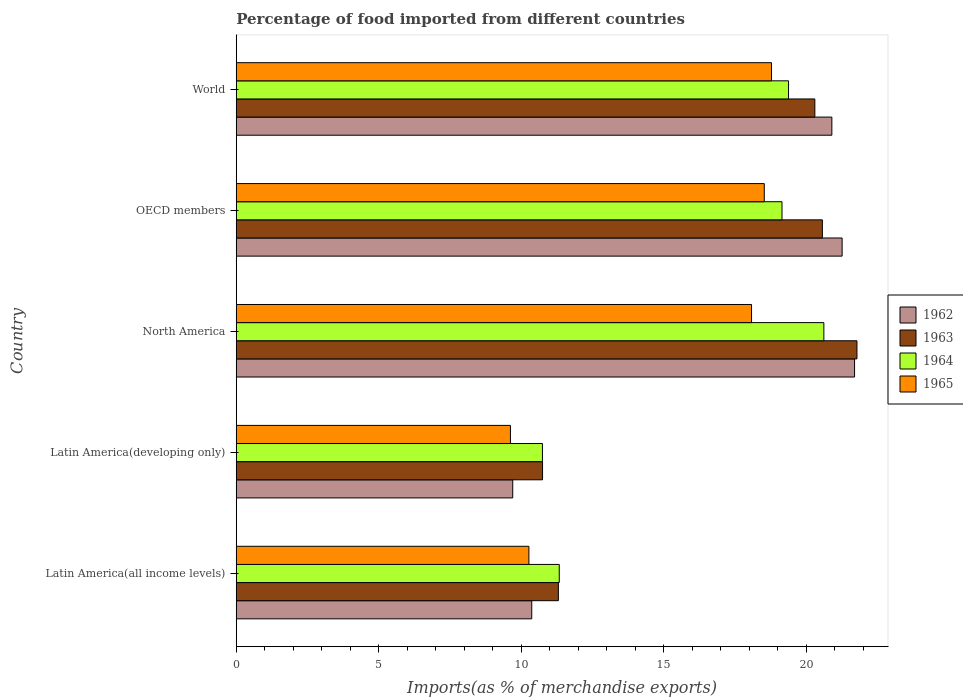How many bars are there on the 3rd tick from the top?
Keep it short and to the point. 4. How many bars are there on the 2nd tick from the bottom?
Make the answer very short. 4. What is the label of the 5th group of bars from the top?
Ensure brevity in your answer.  Latin America(all income levels). What is the percentage of imports to different countries in 1964 in Latin America(developing only)?
Keep it short and to the point. 10.74. Across all countries, what is the maximum percentage of imports to different countries in 1964?
Your answer should be compact. 20.61. Across all countries, what is the minimum percentage of imports to different countries in 1965?
Provide a succinct answer. 9.62. In which country was the percentage of imports to different countries in 1964 maximum?
Offer a terse response. North America. In which country was the percentage of imports to different countries in 1964 minimum?
Make the answer very short. Latin America(developing only). What is the total percentage of imports to different countries in 1964 in the graph?
Offer a very short reply. 81.19. What is the difference between the percentage of imports to different countries in 1962 in Latin America(all income levels) and that in Latin America(developing only)?
Give a very brief answer. 0.67. What is the difference between the percentage of imports to different countries in 1963 in Latin America(all income levels) and the percentage of imports to different countries in 1965 in North America?
Offer a very short reply. -6.78. What is the average percentage of imports to different countries in 1965 per country?
Keep it short and to the point. 15.05. What is the difference between the percentage of imports to different countries in 1964 and percentage of imports to different countries in 1965 in OECD members?
Keep it short and to the point. 0.62. What is the ratio of the percentage of imports to different countries in 1963 in Latin America(developing only) to that in OECD members?
Keep it short and to the point. 0.52. Is the difference between the percentage of imports to different countries in 1964 in North America and World greater than the difference between the percentage of imports to different countries in 1965 in North America and World?
Keep it short and to the point. Yes. What is the difference between the highest and the second highest percentage of imports to different countries in 1965?
Your answer should be compact. 0.25. What is the difference between the highest and the lowest percentage of imports to different countries in 1965?
Provide a succinct answer. 9.16. What does the 2nd bar from the top in Latin America(developing only) represents?
Your answer should be compact. 1964. What does the 1st bar from the bottom in OECD members represents?
Make the answer very short. 1962. Is it the case that in every country, the sum of the percentage of imports to different countries in 1965 and percentage of imports to different countries in 1964 is greater than the percentage of imports to different countries in 1963?
Offer a very short reply. Yes. How many countries are there in the graph?
Ensure brevity in your answer.  5. What is the difference between two consecutive major ticks on the X-axis?
Make the answer very short. 5. Does the graph contain any zero values?
Give a very brief answer. No. Where does the legend appear in the graph?
Ensure brevity in your answer.  Center right. How many legend labels are there?
Your answer should be compact. 4. How are the legend labels stacked?
Your response must be concise. Vertical. What is the title of the graph?
Your response must be concise. Percentage of food imported from different countries. Does "1984" appear as one of the legend labels in the graph?
Provide a short and direct response. No. What is the label or title of the X-axis?
Make the answer very short. Imports(as % of merchandise exports). What is the Imports(as % of merchandise exports) in 1962 in Latin America(all income levels)?
Keep it short and to the point. 10.36. What is the Imports(as % of merchandise exports) in 1963 in Latin America(all income levels)?
Offer a very short reply. 11.3. What is the Imports(as % of merchandise exports) in 1964 in Latin America(all income levels)?
Offer a very short reply. 11.33. What is the Imports(as % of merchandise exports) of 1965 in Latin America(all income levels)?
Your response must be concise. 10.26. What is the Imports(as % of merchandise exports) of 1962 in Latin America(developing only)?
Your response must be concise. 9.7. What is the Imports(as % of merchandise exports) in 1963 in Latin America(developing only)?
Your answer should be very brief. 10.74. What is the Imports(as % of merchandise exports) in 1964 in Latin America(developing only)?
Offer a terse response. 10.74. What is the Imports(as % of merchandise exports) in 1965 in Latin America(developing only)?
Ensure brevity in your answer.  9.62. What is the Imports(as % of merchandise exports) of 1962 in North America?
Your answer should be compact. 21.69. What is the Imports(as % of merchandise exports) of 1963 in North America?
Your answer should be compact. 21.77. What is the Imports(as % of merchandise exports) in 1964 in North America?
Keep it short and to the point. 20.61. What is the Imports(as % of merchandise exports) in 1965 in North America?
Your answer should be very brief. 18.07. What is the Imports(as % of merchandise exports) of 1962 in OECD members?
Offer a terse response. 21.25. What is the Imports(as % of merchandise exports) in 1963 in OECD members?
Your answer should be compact. 20.56. What is the Imports(as % of merchandise exports) of 1964 in OECD members?
Provide a succinct answer. 19.14. What is the Imports(as % of merchandise exports) of 1965 in OECD members?
Your answer should be very brief. 18.52. What is the Imports(as % of merchandise exports) of 1962 in World?
Offer a very short reply. 20.89. What is the Imports(as % of merchandise exports) in 1963 in World?
Your answer should be compact. 20.29. What is the Imports(as % of merchandise exports) of 1964 in World?
Offer a terse response. 19.37. What is the Imports(as % of merchandise exports) in 1965 in World?
Make the answer very short. 18.77. Across all countries, what is the maximum Imports(as % of merchandise exports) of 1962?
Offer a very short reply. 21.69. Across all countries, what is the maximum Imports(as % of merchandise exports) in 1963?
Your answer should be compact. 21.77. Across all countries, what is the maximum Imports(as % of merchandise exports) in 1964?
Give a very brief answer. 20.61. Across all countries, what is the maximum Imports(as % of merchandise exports) in 1965?
Make the answer very short. 18.77. Across all countries, what is the minimum Imports(as % of merchandise exports) in 1962?
Your response must be concise. 9.7. Across all countries, what is the minimum Imports(as % of merchandise exports) of 1963?
Your response must be concise. 10.74. Across all countries, what is the minimum Imports(as % of merchandise exports) in 1964?
Offer a very short reply. 10.74. Across all countries, what is the minimum Imports(as % of merchandise exports) of 1965?
Your answer should be compact. 9.62. What is the total Imports(as % of merchandise exports) in 1962 in the graph?
Provide a succinct answer. 83.89. What is the total Imports(as % of merchandise exports) in 1963 in the graph?
Give a very brief answer. 84.66. What is the total Imports(as % of merchandise exports) in 1964 in the graph?
Offer a very short reply. 81.19. What is the total Imports(as % of merchandise exports) in 1965 in the graph?
Make the answer very short. 75.25. What is the difference between the Imports(as % of merchandise exports) in 1962 in Latin America(all income levels) and that in Latin America(developing only)?
Keep it short and to the point. 0.67. What is the difference between the Imports(as % of merchandise exports) of 1963 in Latin America(all income levels) and that in Latin America(developing only)?
Provide a succinct answer. 0.56. What is the difference between the Imports(as % of merchandise exports) in 1964 in Latin America(all income levels) and that in Latin America(developing only)?
Provide a succinct answer. 0.59. What is the difference between the Imports(as % of merchandise exports) of 1965 in Latin America(all income levels) and that in Latin America(developing only)?
Your response must be concise. 0.65. What is the difference between the Imports(as % of merchandise exports) in 1962 in Latin America(all income levels) and that in North America?
Your response must be concise. -11.32. What is the difference between the Imports(as % of merchandise exports) in 1963 in Latin America(all income levels) and that in North America?
Offer a terse response. -10.47. What is the difference between the Imports(as % of merchandise exports) in 1964 in Latin America(all income levels) and that in North America?
Give a very brief answer. -9.28. What is the difference between the Imports(as % of merchandise exports) of 1965 in Latin America(all income levels) and that in North America?
Your response must be concise. -7.81. What is the difference between the Imports(as % of merchandise exports) in 1962 in Latin America(all income levels) and that in OECD members?
Make the answer very short. -10.89. What is the difference between the Imports(as % of merchandise exports) of 1963 in Latin America(all income levels) and that in OECD members?
Offer a very short reply. -9.26. What is the difference between the Imports(as % of merchandise exports) in 1964 in Latin America(all income levels) and that in OECD members?
Keep it short and to the point. -7.81. What is the difference between the Imports(as % of merchandise exports) of 1965 in Latin America(all income levels) and that in OECD members?
Your answer should be compact. -8.26. What is the difference between the Imports(as % of merchandise exports) of 1962 in Latin America(all income levels) and that in World?
Your answer should be very brief. -10.53. What is the difference between the Imports(as % of merchandise exports) in 1963 in Latin America(all income levels) and that in World?
Your answer should be very brief. -9. What is the difference between the Imports(as % of merchandise exports) in 1964 in Latin America(all income levels) and that in World?
Offer a very short reply. -8.04. What is the difference between the Imports(as % of merchandise exports) of 1965 in Latin America(all income levels) and that in World?
Provide a succinct answer. -8.51. What is the difference between the Imports(as % of merchandise exports) of 1962 in Latin America(developing only) and that in North America?
Your answer should be very brief. -11.99. What is the difference between the Imports(as % of merchandise exports) of 1963 in Latin America(developing only) and that in North America?
Your answer should be compact. -11.03. What is the difference between the Imports(as % of merchandise exports) in 1964 in Latin America(developing only) and that in North America?
Your answer should be compact. -9.87. What is the difference between the Imports(as % of merchandise exports) in 1965 in Latin America(developing only) and that in North America?
Make the answer very short. -8.46. What is the difference between the Imports(as % of merchandise exports) in 1962 in Latin America(developing only) and that in OECD members?
Your answer should be very brief. -11.55. What is the difference between the Imports(as % of merchandise exports) of 1963 in Latin America(developing only) and that in OECD members?
Ensure brevity in your answer.  -9.82. What is the difference between the Imports(as % of merchandise exports) in 1964 in Latin America(developing only) and that in OECD members?
Offer a very short reply. -8.4. What is the difference between the Imports(as % of merchandise exports) of 1965 in Latin America(developing only) and that in OECD members?
Provide a succinct answer. -8.9. What is the difference between the Imports(as % of merchandise exports) in 1962 in Latin America(developing only) and that in World?
Provide a succinct answer. -11.19. What is the difference between the Imports(as % of merchandise exports) in 1963 in Latin America(developing only) and that in World?
Offer a very short reply. -9.55. What is the difference between the Imports(as % of merchandise exports) in 1964 in Latin America(developing only) and that in World?
Provide a short and direct response. -8.63. What is the difference between the Imports(as % of merchandise exports) of 1965 in Latin America(developing only) and that in World?
Offer a very short reply. -9.16. What is the difference between the Imports(as % of merchandise exports) of 1962 in North America and that in OECD members?
Your answer should be compact. 0.44. What is the difference between the Imports(as % of merchandise exports) in 1963 in North America and that in OECD members?
Your response must be concise. 1.21. What is the difference between the Imports(as % of merchandise exports) in 1964 in North America and that in OECD members?
Ensure brevity in your answer.  1.47. What is the difference between the Imports(as % of merchandise exports) of 1965 in North America and that in OECD members?
Your answer should be compact. -0.45. What is the difference between the Imports(as % of merchandise exports) of 1962 in North America and that in World?
Offer a terse response. 0.8. What is the difference between the Imports(as % of merchandise exports) of 1963 in North America and that in World?
Your response must be concise. 1.48. What is the difference between the Imports(as % of merchandise exports) of 1964 in North America and that in World?
Your answer should be compact. 1.24. What is the difference between the Imports(as % of merchandise exports) in 1965 in North America and that in World?
Keep it short and to the point. -0.7. What is the difference between the Imports(as % of merchandise exports) in 1962 in OECD members and that in World?
Offer a very short reply. 0.36. What is the difference between the Imports(as % of merchandise exports) in 1963 in OECD members and that in World?
Make the answer very short. 0.26. What is the difference between the Imports(as % of merchandise exports) of 1964 in OECD members and that in World?
Your answer should be very brief. -0.23. What is the difference between the Imports(as % of merchandise exports) of 1965 in OECD members and that in World?
Ensure brevity in your answer.  -0.25. What is the difference between the Imports(as % of merchandise exports) of 1962 in Latin America(all income levels) and the Imports(as % of merchandise exports) of 1963 in Latin America(developing only)?
Make the answer very short. -0.38. What is the difference between the Imports(as % of merchandise exports) in 1962 in Latin America(all income levels) and the Imports(as % of merchandise exports) in 1964 in Latin America(developing only)?
Ensure brevity in your answer.  -0.37. What is the difference between the Imports(as % of merchandise exports) in 1962 in Latin America(all income levels) and the Imports(as % of merchandise exports) in 1965 in Latin America(developing only)?
Your response must be concise. 0.75. What is the difference between the Imports(as % of merchandise exports) in 1963 in Latin America(all income levels) and the Imports(as % of merchandise exports) in 1964 in Latin America(developing only)?
Give a very brief answer. 0.56. What is the difference between the Imports(as % of merchandise exports) of 1963 in Latin America(all income levels) and the Imports(as % of merchandise exports) of 1965 in Latin America(developing only)?
Give a very brief answer. 1.68. What is the difference between the Imports(as % of merchandise exports) in 1964 in Latin America(all income levels) and the Imports(as % of merchandise exports) in 1965 in Latin America(developing only)?
Provide a short and direct response. 1.71. What is the difference between the Imports(as % of merchandise exports) of 1962 in Latin America(all income levels) and the Imports(as % of merchandise exports) of 1963 in North America?
Your answer should be compact. -11.41. What is the difference between the Imports(as % of merchandise exports) in 1962 in Latin America(all income levels) and the Imports(as % of merchandise exports) in 1964 in North America?
Offer a very short reply. -10.25. What is the difference between the Imports(as % of merchandise exports) in 1962 in Latin America(all income levels) and the Imports(as % of merchandise exports) in 1965 in North America?
Make the answer very short. -7.71. What is the difference between the Imports(as % of merchandise exports) in 1963 in Latin America(all income levels) and the Imports(as % of merchandise exports) in 1964 in North America?
Give a very brief answer. -9.31. What is the difference between the Imports(as % of merchandise exports) in 1963 in Latin America(all income levels) and the Imports(as % of merchandise exports) in 1965 in North America?
Your answer should be compact. -6.78. What is the difference between the Imports(as % of merchandise exports) in 1964 in Latin America(all income levels) and the Imports(as % of merchandise exports) in 1965 in North America?
Offer a terse response. -6.74. What is the difference between the Imports(as % of merchandise exports) of 1962 in Latin America(all income levels) and the Imports(as % of merchandise exports) of 1963 in OECD members?
Make the answer very short. -10.19. What is the difference between the Imports(as % of merchandise exports) of 1962 in Latin America(all income levels) and the Imports(as % of merchandise exports) of 1964 in OECD members?
Your response must be concise. -8.78. What is the difference between the Imports(as % of merchandise exports) in 1962 in Latin America(all income levels) and the Imports(as % of merchandise exports) in 1965 in OECD members?
Offer a very short reply. -8.16. What is the difference between the Imports(as % of merchandise exports) in 1963 in Latin America(all income levels) and the Imports(as % of merchandise exports) in 1964 in OECD members?
Make the answer very short. -7.84. What is the difference between the Imports(as % of merchandise exports) of 1963 in Latin America(all income levels) and the Imports(as % of merchandise exports) of 1965 in OECD members?
Give a very brief answer. -7.22. What is the difference between the Imports(as % of merchandise exports) in 1964 in Latin America(all income levels) and the Imports(as % of merchandise exports) in 1965 in OECD members?
Ensure brevity in your answer.  -7.19. What is the difference between the Imports(as % of merchandise exports) of 1962 in Latin America(all income levels) and the Imports(as % of merchandise exports) of 1963 in World?
Give a very brief answer. -9.93. What is the difference between the Imports(as % of merchandise exports) in 1962 in Latin America(all income levels) and the Imports(as % of merchandise exports) in 1964 in World?
Offer a very short reply. -9.01. What is the difference between the Imports(as % of merchandise exports) of 1962 in Latin America(all income levels) and the Imports(as % of merchandise exports) of 1965 in World?
Your answer should be very brief. -8.41. What is the difference between the Imports(as % of merchandise exports) in 1963 in Latin America(all income levels) and the Imports(as % of merchandise exports) in 1964 in World?
Provide a short and direct response. -8.07. What is the difference between the Imports(as % of merchandise exports) in 1963 in Latin America(all income levels) and the Imports(as % of merchandise exports) in 1965 in World?
Provide a succinct answer. -7.47. What is the difference between the Imports(as % of merchandise exports) in 1964 in Latin America(all income levels) and the Imports(as % of merchandise exports) in 1965 in World?
Ensure brevity in your answer.  -7.44. What is the difference between the Imports(as % of merchandise exports) in 1962 in Latin America(developing only) and the Imports(as % of merchandise exports) in 1963 in North America?
Provide a succinct answer. -12.07. What is the difference between the Imports(as % of merchandise exports) of 1962 in Latin America(developing only) and the Imports(as % of merchandise exports) of 1964 in North America?
Offer a very short reply. -10.91. What is the difference between the Imports(as % of merchandise exports) of 1962 in Latin America(developing only) and the Imports(as % of merchandise exports) of 1965 in North America?
Make the answer very short. -8.38. What is the difference between the Imports(as % of merchandise exports) of 1963 in Latin America(developing only) and the Imports(as % of merchandise exports) of 1964 in North America?
Your response must be concise. -9.87. What is the difference between the Imports(as % of merchandise exports) of 1963 in Latin America(developing only) and the Imports(as % of merchandise exports) of 1965 in North America?
Make the answer very short. -7.33. What is the difference between the Imports(as % of merchandise exports) of 1964 in Latin America(developing only) and the Imports(as % of merchandise exports) of 1965 in North America?
Ensure brevity in your answer.  -7.33. What is the difference between the Imports(as % of merchandise exports) in 1962 in Latin America(developing only) and the Imports(as % of merchandise exports) in 1963 in OECD members?
Give a very brief answer. -10.86. What is the difference between the Imports(as % of merchandise exports) of 1962 in Latin America(developing only) and the Imports(as % of merchandise exports) of 1964 in OECD members?
Your response must be concise. -9.44. What is the difference between the Imports(as % of merchandise exports) in 1962 in Latin America(developing only) and the Imports(as % of merchandise exports) in 1965 in OECD members?
Provide a succinct answer. -8.82. What is the difference between the Imports(as % of merchandise exports) in 1963 in Latin America(developing only) and the Imports(as % of merchandise exports) in 1964 in OECD members?
Give a very brief answer. -8.4. What is the difference between the Imports(as % of merchandise exports) of 1963 in Latin America(developing only) and the Imports(as % of merchandise exports) of 1965 in OECD members?
Offer a very short reply. -7.78. What is the difference between the Imports(as % of merchandise exports) in 1964 in Latin America(developing only) and the Imports(as % of merchandise exports) in 1965 in OECD members?
Offer a terse response. -7.78. What is the difference between the Imports(as % of merchandise exports) in 1962 in Latin America(developing only) and the Imports(as % of merchandise exports) in 1963 in World?
Offer a terse response. -10.6. What is the difference between the Imports(as % of merchandise exports) in 1962 in Latin America(developing only) and the Imports(as % of merchandise exports) in 1964 in World?
Ensure brevity in your answer.  -9.67. What is the difference between the Imports(as % of merchandise exports) of 1962 in Latin America(developing only) and the Imports(as % of merchandise exports) of 1965 in World?
Your answer should be compact. -9.08. What is the difference between the Imports(as % of merchandise exports) of 1963 in Latin America(developing only) and the Imports(as % of merchandise exports) of 1964 in World?
Ensure brevity in your answer.  -8.63. What is the difference between the Imports(as % of merchandise exports) of 1963 in Latin America(developing only) and the Imports(as % of merchandise exports) of 1965 in World?
Provide a succinct answer. -8.03. What is the difference between the Imports(as % of merchandise exports) in 1964 in Latin America(developing only) and the Imports(as % of merchandise exports) in 1965 in World?
Ensure brevity in your answer.  -8.03. What is the difference between the Imports(as % of merchandise exports) in 1962 in North America and the Imports(as % of merchandise exports) in 1963 in OECD members?
Make the answer very short. 1.13. What is the difference between the Imports(as % of merchandise exports) in 1962 in North America and the Imports(as % of merchandise exports) in 1964 in OECD members?
Your answer should be compact. 2.55. What is the difference between the Imports(as % of merchandise exports) in 1962 in North America and the Imports(as % of merchandise exports) in 1965 in OECD members?
Ensure brevity in your answer.  3.17. What is the difference between the Imports(as % of merchandise exports) of 1963 in North America and the Imports(as % of merchandise exports) of 1964 in OECD members?
Provide a short and direct response. 2.63. What is the difference between the Imports(as % of merchandise exports) in 1963 in North America and the Imports(as % of merchandise exports) in 1965 in OECD members?
Offer a very short reply. 3.25. What is the difference between the Imports(as % of merchandise exports) in 1964 in North America and the Imports(as % of merchandise exports) in 1965 in OECD members?
Provide a succinct answer. 2.09. What is the difference between the Imports(as % of merchandise exports) in 1962 in North America and the Imports(as % of merchandise exports) in 1963 in World?
Your answer should be compact. 1.39. What is the difference between the Imports(as % of merchandise exports) of 1962 in North America and the Imports(as % of merchandise exports) of 1964 in World?
Provide a succinct answer. 2.32. What is the difference between the Imports(as % of merchandise exports) of 1962 in North America and the Imports(as % of merchandise exports) of 1965 in World?
Your answer should be very brief. 2.91. What is the difference between the Imports(as % of merchandise exports) in 1963 in North America and the Imports(as % of merchandise exports) in 1964 in World?
Your answer should be compact. 2.4. What is the difference between the Imports(as % of merchandise exports) in 1963 in North America and the Imports(as % of merchandise exports) in 1965 in World?
Your response must be concise. 3. What is the difference between the Imports(as % of merchandise exports) in 1964 in North America and the Imports(as % of merchandise exports) in 1965 in World?
Make the answer very short. 1.84. What is the difference between the Imports(as % of merchandise exports) in 1962 in OECD members and the Imports(as % of merchandise exports) in 1963 in World?
Offer a terse response. 0.96. What is the difference between the Imports(as % of merchandise exports) in 1962 in OECD members and the Imports(as % of merchandise exports) in 1964 in World?
Keep it short and to the point. 1.88. What is the difference between the Imports(as % of merchandise exports) in 1962 in OECD members and the Imports(as % of merchandise exports) in 1965 in World?
Ensure brevity in your answer.  2.48. What is the difference between the Imports(as % of merchandise exports) of 1963 in OECD members and the Imports(as % of merchandise exports) of 1964 in World?
Provide a short and direct response. 1.19. What is the difference between the Imports(as % of merchandise exports) in 1963 in OECD members and the Imports(as % of merchandise exports) in 1965 in World?
Your response must be concise. 1.78. What is the difference between the Imports(as % of merchandise exports) of 1964 in OECD members and the Imports(as % of merchandise exports) of 1965 in World?
Your answer should be compact. 0.37. What is the average Imports(as % of merchandise exports) in 1962 per country?
Provide a succinct answer. 16.78. What is the average Imports(as % of merchandise exports) in 1963 per country?
Ensure brevity in your answer.  16.93. What is the average Imports(as % of merchandise exports) of 1964 per country?
Keep it short and to the point. 16.24. What is the average Imports(as % of merchandise exports) of 1965 per country?
Your response must be concise. 15.05. What is the difference between the Imports(as % of merchandise exports) in 1962 and Imports(as % of merchandise exports) in 1963 in Latin America(all income levels)?
Your answer should be very brief. -0.93. What is the difference between the Imports(as % of merchandise exports) in 1962 and Imports(as % of merchandise exports) in 1964 in Latin America(all income levels)?
Your answer should be compact. -0.96. What is the difference between the Imports(as % of merchandise exports) in 1962 and Imports(as % of merchandise exports) in 1965 in Latin America(all income levels)?
Offer a very short reply. 0.1. What is the difference between the Imports(as % of merchandise exports) of 1963 and Imports(as % of merchandise exports) of 1964 in Latin America(all income levels)?
Offer a very short reply. -0.03. What is the difference between the Imports(as % of merchandise exports) in 1963 and Imports(as % of merchandise exports) in 1965 in Latin America(all income levels)?
Offer a very short reply. 1.03. What is the difference between the Imports(as % of merchandise exports) of 1964 and Imports(as % of merchandise exports) of 1965 in Latin America(all income levels)?
Your response must be concise. 1.07. What is the difference between the Imports(as % of merchandise exports) in 1962 and Imports(as % of merchandise exports) in 1963 in Latin America(developing only)?
Offer a terse response. -1.05. What is the difference between the Imports(as % of merchandise exports) of 1962 and Imports(as % of merchandise exports) of 1964 in Latin America(developing only)?
Make the answer very short. -1.04. What is the difference between the Imports(as % of merchandise exports) of 1962 and Imports(as % of merchandise exports) of 1965 in Latin America(developing only)?
Provide a short and direct response. 0.08. What is the difference between the Imports(as % of merchandise exports) of 1963 and Imports(as % of merchandise exports) of 1964 in Latin America(developing only)?
Offer a terse response. 0. What is the difference between the Imports(as % of merchandise exports) of 1963 and Imports(as % of merchandise exports) of 1965 in Latin America(developing only)?
Your answer should be very brief. 1.13. What is the difference between the Imports(as % of merchandise exports) in 1964 and Imports(as % of merchandise exports) in 1965 in Latin America(developing only)?
Give a very brief answer. 1.12. What is the difference between the Imports(as % of merchandise exports) of 1962 and Imports(as % of merchandise exports) of 1963 in North America?
Offer a very short reply. -0.08. What is the difference between the Imports(as % of merchandise exports) of 1962 and Imports(as % of merchandise exports) of 1964 in North America?
Your answer should be compact. 1.08. What is the difference between the Imports(as % of merchandise exports) of 1962 and Imports(as % of merchandise exports) of 1965 in North America?
Provide a succinct answer. 3.61. What is the difference between the Imports(as % of merchandise exports) of 1963 and Imports(as % of merchandise exports) of 1964 in North America?
Offer a terse response. 1.16. What is the difference between the Imports(as % of merchandise exports) in 1963 and Imports(as % of merchandise exports) in 1965 in North America?
Provide a succinct answer. 3.7. What is the difference between the Imports(as % of merchandise exports) in 1964 and Imports(as % of merchandise exports) in 1965 in North America?
Your answer should be very brief. 2.54. What is the difference between the Imports(as % of merchandise exports) of 1962 and Imports(as % of merchandise exports) of 1963 in OECD members?
Your response must be concise. 0.69. What is the difference between the Imports(as % of merchandise exports) in 1962 and Imports(as % of merchandise exports) in 1964 in OECD members?
Keep it short and to the point. 2.11. What is the difference between the Imports(as % of merchandise exports) of 1962 and Imports(as % of merchandise exports) of 1965 in OECD members?
Give a very brief answer. 2.73. What is the difference between the Imports(as % of merchandise exports) in 1963 and Imports(as % of merchandise exports) in 1964 in OECD members?
Offer a terse response. 1.42. What is the difference between the Imports(as % of merchandise exports) in 1963 and Imports(as % of merchandise exports) in 1965 in OECD members?
Give a very brief answer. 2.04. What is the difference between the Imports(as % of merchandise exports) of 1964 and Imports(as % of merchandise exports) of 1965 in OECD members?
Your answer should be very brief. 0.62. What is the difference between the Imports(as % of merchandise exports) in 1962 and Imports(as % of merchandise exports) in 1963 in World?
Give a very brief answer. 0.6. What is the difference between the Imports(as % of merchandise exports) in 1962 and Imports(as % of merchandise exports) in 1964 in World?
Offer a very short reply. 1.52. What is the difference between the Imports(as % of merchandise exports) of 1962 and Imports(as % of merchandise exports) of 1965 in World?
Give a very brief answer. 2.12. What is the difference between the Imports(as % of merchandise exports) of 1963 and Imports(as % of merchandise exports) of 1964 in World?
Offer a terse response. 0.92. What is the difference between the Imports(as % of merchandise exports) of 1963 and Imports(as % of merchandise exports) of 1965 in World?
Give a very brief answer. 1.52. What is the difference between the Imports(as % of merchandise exports) in 1964 and Imports(as % of merchandise exports) in 1965 in World?
Provide a short and direct response. 0.6. What is the ratio of the Imports(as % of merchandise exports) in 1962 in Latin America(all income levels) to that in Latin America(developing only)?
Your answer should be compact. 1.07. What is the ratio of the Imports(as % of merchandise exports) of 1963 in Latin America(all income levels) to that in Latin America(developing only)?
Provide a short and direct response. 1.05. What is the ratio of the Imports(as % of merchandise exports) of 1964 in Latin America(all income levels) to that in Latin America(developing only)?
Offer a very short reply. 1.05. What is the ratio of the Imports(as % of merchandise exports) in 1965 in Latin America(all income levels) to that in Latin America(developing only)?
Offer a terse response. 1.07. What is the ratio of the Imports(as % of merchandise exports) of 1962 in Latin America(all income levels) to that in North America?
Give a very brief answer. 0.48. What is the ratio of the Imports(as % of merchandise exports) in 1963 in Latin America(all income levels) to that in North America?
Offer a very short reply. 0.52. What is the ratio of the Imports(as % of merchandise exports) in 1964 in Latin America(all income levels) to that in North America?
Your answer should be very brief. 0.55. What is the ratio of the Imports(as % of merchandise exports) in 1965 in Latin America(all income levels) to that in North America?
Provide a succinct answer. 0.57. What is the ratio of the Imports(as % of merchandise exports) of 1962 in Latin America(all income levels) to that in OECD members?
Make the answer very short. 0.49. What is the ratio of the Imports(as % of merchandise exports) in 1963 in Latin America(all income levels) to that in OECD members?
Make the answer very short. 0.55. What is the ratio of the Imports(as % of merchandise exports) of 1964 in Latin America(all income levels) to that in OECD members?
Make the answer very short. 0.59. What is the ratio of the Imports(as % of merchandise exports) of 1965 in Latin America(all income levels) to that in OECD members?
Your answer should be very brief. 0.55. What is the ratio of the Imports(as % of merchandise exports) in 1962 in Latin America(all income levels) to that in World?
Your response must be concise. 0.5. What is the ratio of the Imports(as % of merchandise exports) of 1963 in Latin America(all income levels) to that in World?
Make the answer very short. 0.56. What is the ratio of the Imports(as % of merchandise exports) in 1964 in Latin America(all income levels) to that in World?
Give a very brief answer. 0.58. What is the ratio of the Imports(as % of merchandise exports) in 1965 in Latin America(all income levels) to that in World?
Your answer should be compact. 0.55. What is the ratio of the Imports(as % of merchandise exports) in 1962 in Latin America(developing only) to that in North America?
Ensure brevity in your answer.  0.45. What is the ratio of the Imports(as % of merchandise exports) of 1963 in Latin America(developing only) to that in North America?
Give a very brief answer. 0.49. What is the ratio of the Imports(as % of merchandise exports) of 1964 in Latin America(developing only) to that in North America?
Offer a terse response. 0.52. What is the ratio of the Imports(as % of merchandise exports) of 1965 in Latin America(developing only) to that in North America?
Ensure brevity in your answer.  0.53. What is the ratio of the Imports(as % of merchandise exports) of 1962 in Latin America(developing only) to that in OECD members?
Offer a terse response. 0.46. What is the ratio of the Imports(as % of merchandise exports) of 1963 in Latin America(developing only) to that in OECD members?
Your answer should be very brief. 0.52. What is the ratio of the Imports(as % of merchandise exports) in 1964 in Latin America(developing only) to that in OECD members?
Your response must be concise. 0.56. What is the ratio of the Imports(as % of merchandise exports) in 1965 in Latin America(developing only) to that in OECD members?
Your answer should be compact. 0.52. What is the ratio of the Imports(as % of merchandise exports) in 1962 in Latin America(developing only) to that in World?
Your answer should be very brief. 0.46. What is the ratio of the Imports(as % of merchandise exports) of 1963 in Latin America(developing only) to that in World?
Provide a short and direct response. 0.53. What is the ratio of the Imports(as % of merchandise exports) of 1964 in Latin America(developing only) to that in World?
Ensure brevity in your answer.  0.55. What is the ratio of the Imports(as % of merchandise exports) in 1965 in Latin America(developing only) to that in World?
Offer a very short reply. 0.51. What is the ratio of the Imports(as % of merchandise exports) in 1962 in North America to that in OECD members?
Offer a very short reply. 1.02. What is the ratio of the Imports(as % of merchandise exports) in 1963 in North America to that in OECD members?
Ensure brevity in your answer.  1.06. What is the ratio of the Imports(as % of merchandise exports) of 1964 in North America to that in OECD members?
Ensure brevity in your answer.  1.08. What is the ratio of the Imports(as % of merchandise exports) in 1965 in North America to that in OECD members?
Provide a short and direct response. 0.98. What is the ratio of the Imports(as % of merchandise exports) of 1962 in North America to that in World?
Give a very brief answer. 1.04. What is the ratio of the Imports(as % of merchandise exports) in 1963 in North America to that in World?
Provide a short and direct response. 1.07. What is the ratio of the Imports(as % of merchandise exports) in 1964 in North America to that in World?
Offer a terse response. 1.06. What is the ratio of the Imports(as % of merchandise exports) in 1965 in North America to that in World?
Your answer should be compact. 0.96. What is the ratio of the Imports(as % of merchandise exports) of 1962 in OECD members to that in World?
Provide a succinct answer. 1.02. What is the ratio of the Imports(as % of merchandise exports) of 1964 in OECD members to that in World?
Give a very brief answer. 0.99. What is the ratio of the Imports(as % of merchandise exports) in 1965 in OECD members to that in World?
Keep it short and to the point. 0.99. What is the difference between the highest and the second highest Imports(as % of merchandise exports) of 1962?
Offer a terse response. 0.44. What is the difference between the highest and the second highest Imports(as % of merchandise exports) in 1963?
Your answer should be very brief. 1.21. What is the difference between the highest and the second highest Imports(as % of merchandise exports) in 1964?
Make the answer very short. 1.24. What is the difference between the highest and the second highest Imports(as % of merchandise exports) of 1965?
Your answer should be very brief. 0.25. What is the difference between the highest and the lowest Imports(as % of merchandise exports) in 1962?
Give a very brief answer. 11.99. What is the difference between the highest and the lowest Imports(as % of merchandise exports) in 1963?
Offer a very short reply. 11.03. What is the difference between the highest and the lowest Imports(as % of merchandise exports) of 1964?
Your answer should be compact. 9.87. What is the difference between the highest and the lowest Imports(as % of merchandise exports) in 1965?
Give a very brief answer. 9.16. 